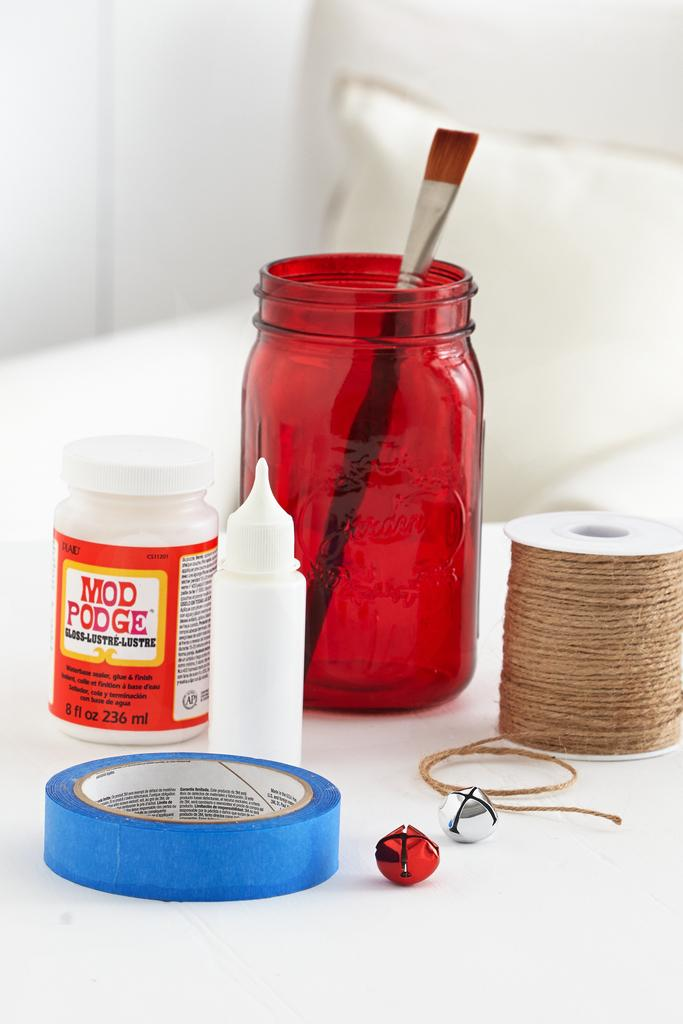<image>
Provide a brief description of the given image. A bottle of Mod Podge glue sitting next to several other items on a table. 